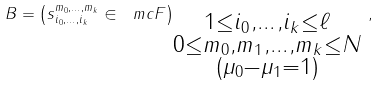<formula> <loc_0><loc_0><loc_500><loc_500>B = \left ( s ^ { m _ { 0 } , \dots , m _ { k } } _ { i _ { 0 } , \dots , i _ { k } } \in \ m c F \right ) _ { \substack { 1 \leq i _ { 0 } , \dots , i _ { k } \leq \ell \\ 0 \leq m _ { 0 } , m _ { 1 } , \dots , m _ { k } \leq N \\ ( \mu _ { 0 } - \mu _ { 1 } = 1 ) } } \, ,</formula> 